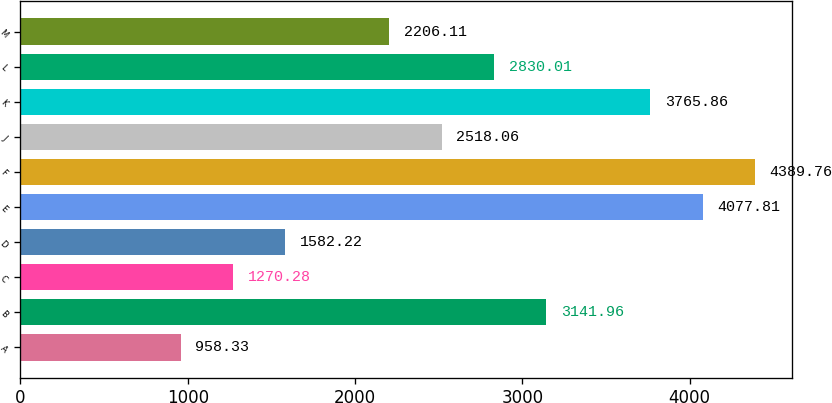<chart> <loc_0><loc_0><loc_500><loc_500><bar_chart><fcel>A<fcel>B<fcel>C<fcel>D<fcel>E<fcel>F<fcel>J<fcel>K<fcel>L<fcel>M<nl><fcel>958.33<fcel>3141.96<fcel>1270.28<fcel>1582.22<fcel>4077.81<fcel>4389.76<fcel>2518.06<fcel>3765.86<fcel>2830.01<fcel>2206.11<nl></chart> 